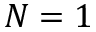Convert formula to latex. <formula><loc_0><loc_0><loc_500><loc_500>N = 1</formula> 